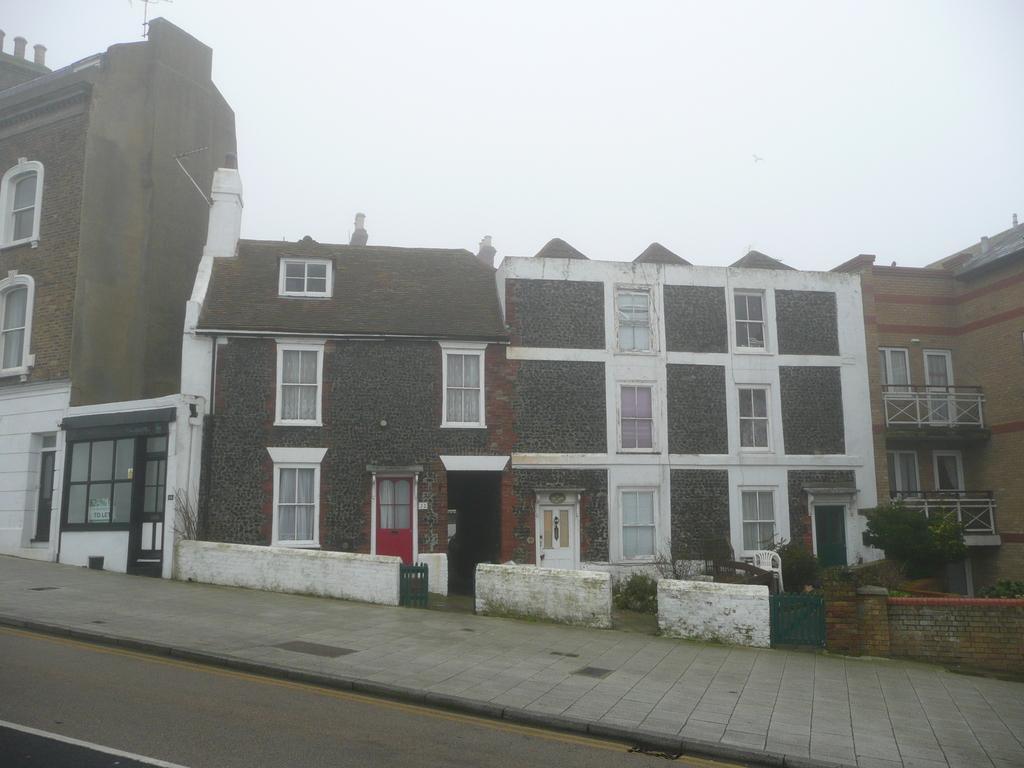How would you summarize this image in a sentence or two? In this image I see number of buildings and I see the walls and I see few plants and I see the path over here. In the background I see the sky. 